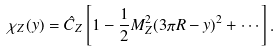Convert formula to latex. <formula><loc_0><loc_0><loc_500><loc_500>\chi _ { Z } ( y ) = \hat { C } _ { Z } \left [ 1 - \frac { 1 } { 2 } M _ { Z } ^ { 2 } ( 3 \pi R - y ) ^ { 2 } + \cdots \right ] .</formula> 